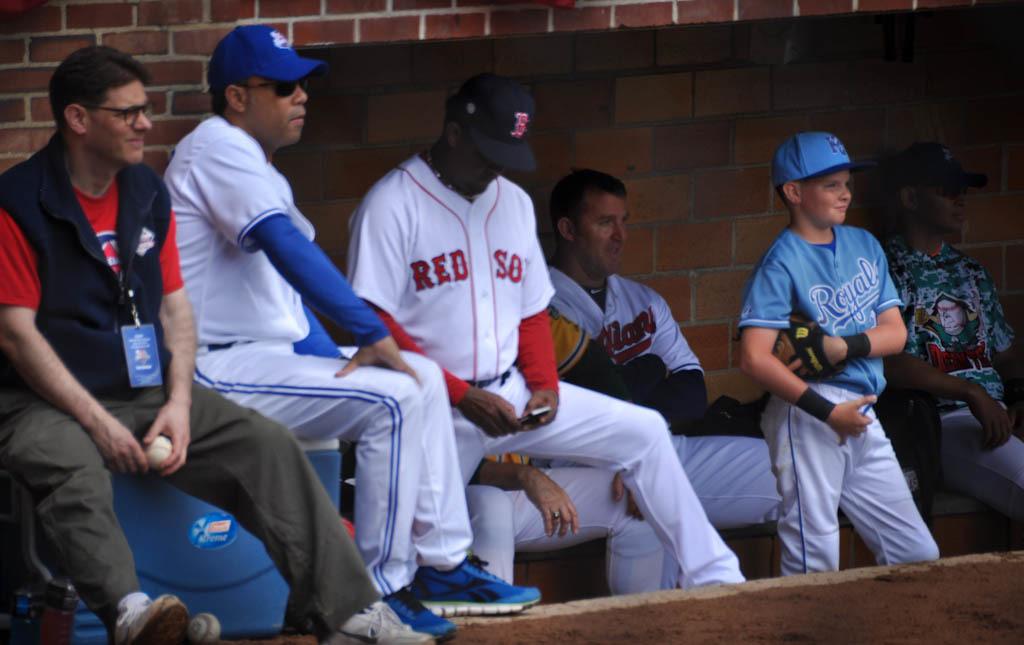What team jersey does the boy have on?
Keep it short and to the point. Royals. What team is in white?
Give a very brief answer. Red sox. 